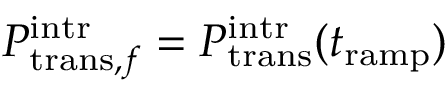Convert formula to latex. <formula><loc_0><loc_0><loc_500><loc_500>P _ { t r a n s , f } ^ { i n t r } = P _ { t r a n s } ^ { i n t r } ( t _ { r a m p } )</formula> 